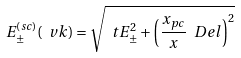Convert formula to latex. <formula><loc_0><loc_0><loc_500><loc_500>E ^ { ( s c ) } _ { \pm } ( \ v k ) = \sqrt { \ t E _ { \pm } ^ { 2 } + \left ( \frac { x _ { p c } } { x } \ D e l \right ) ^ { 2 } }</formula> 